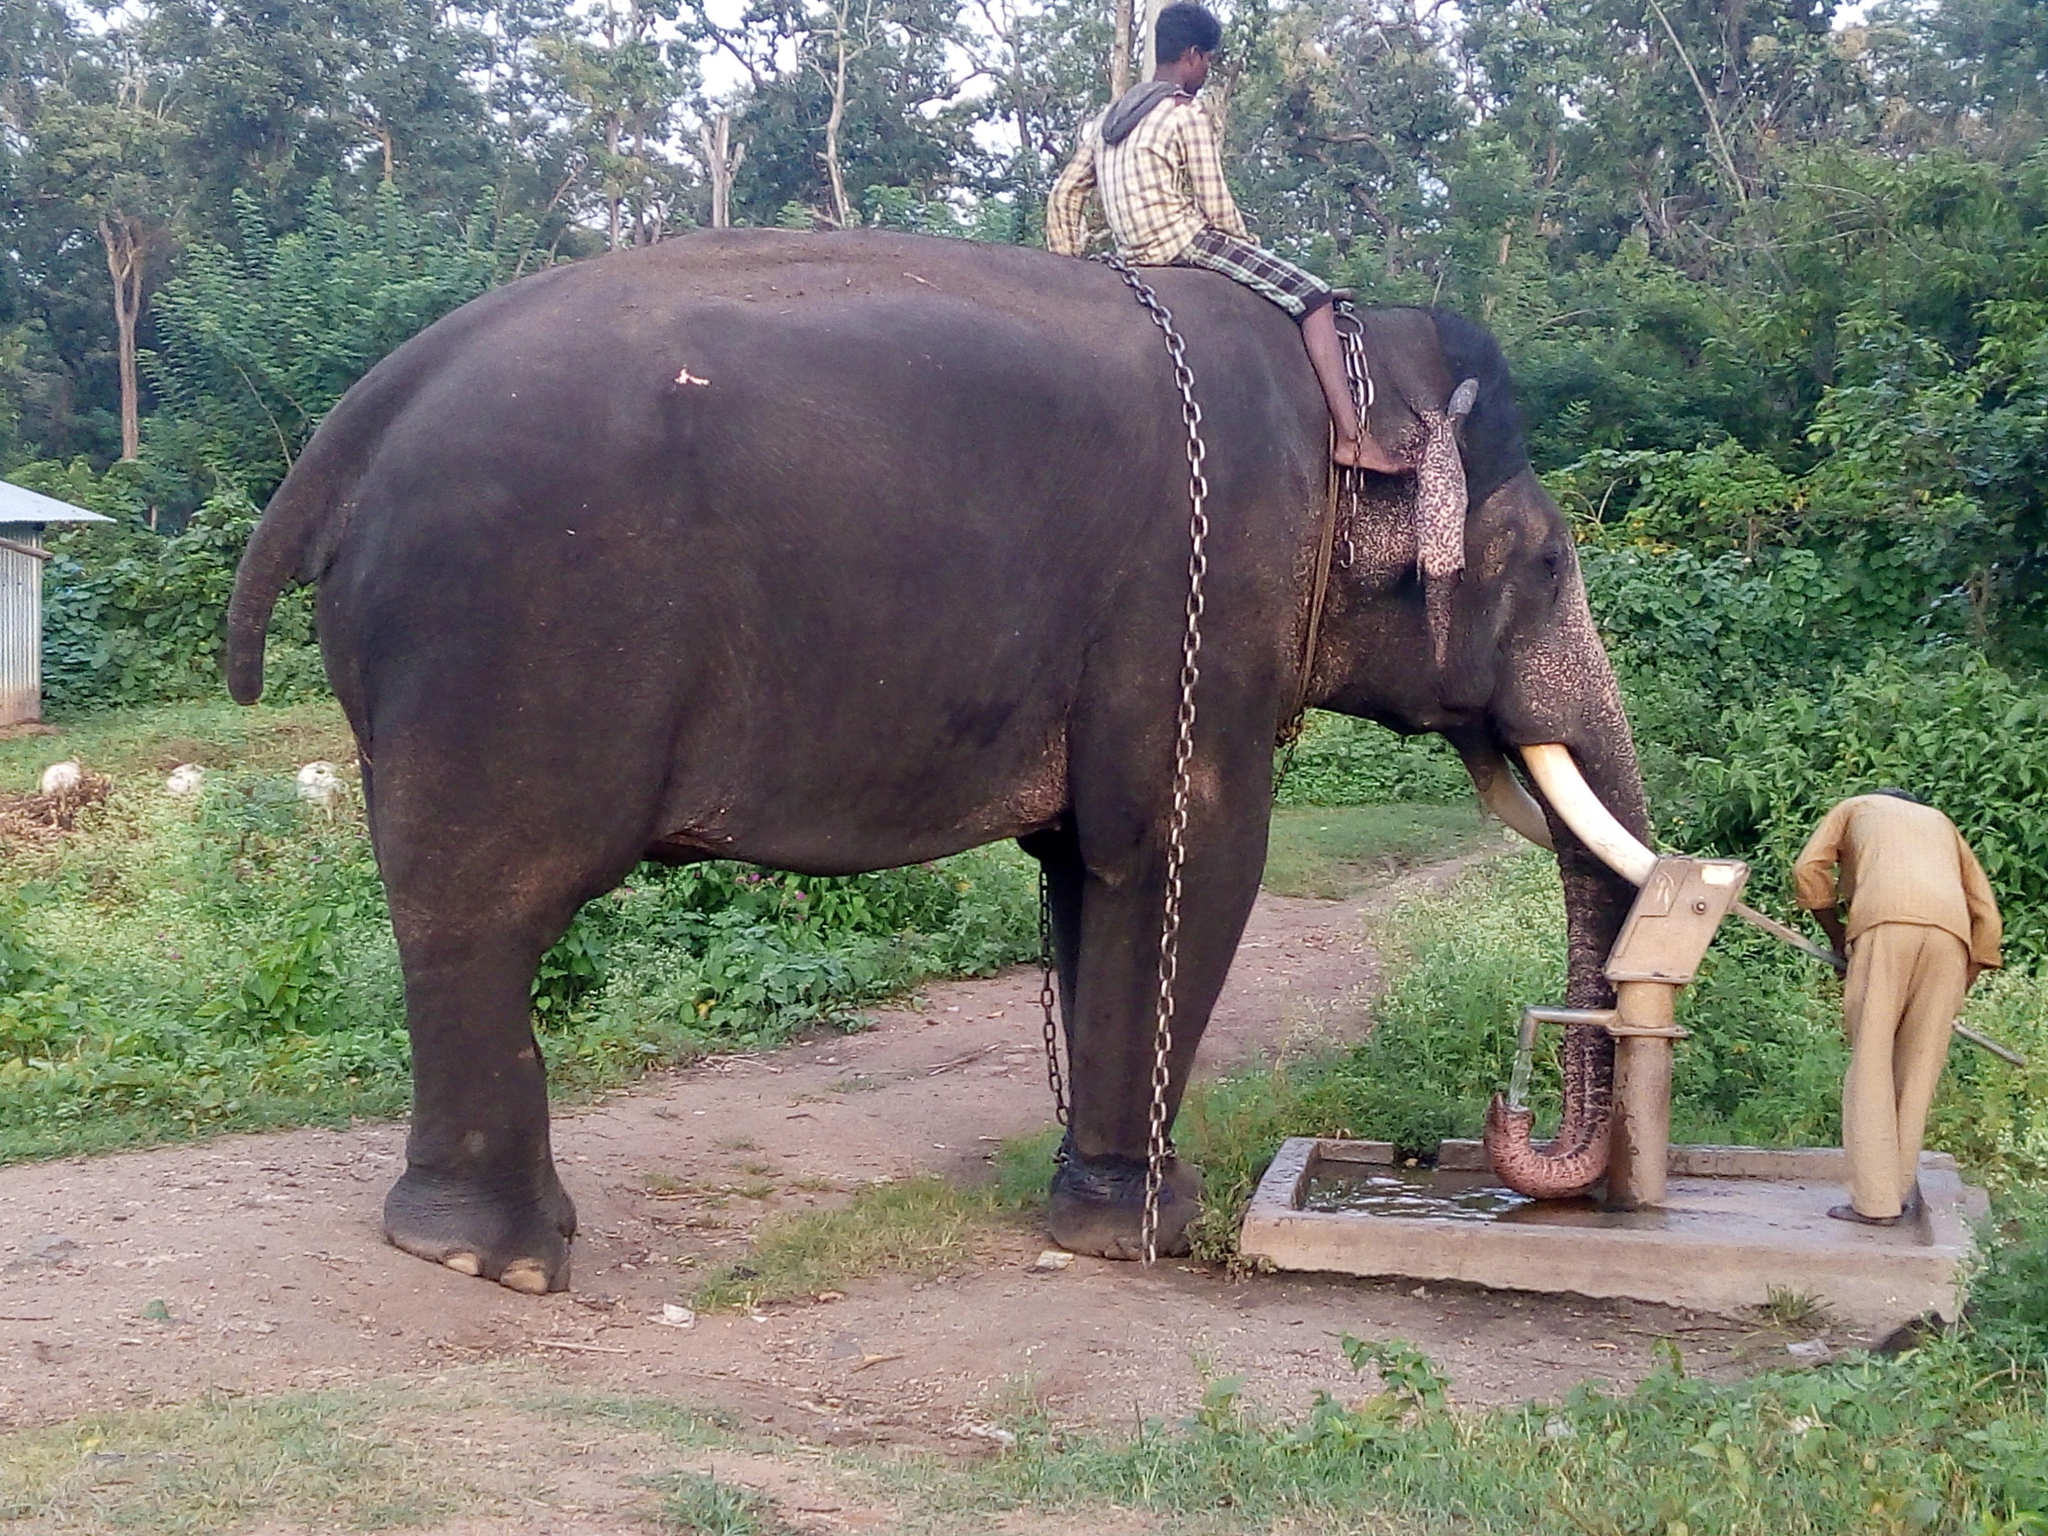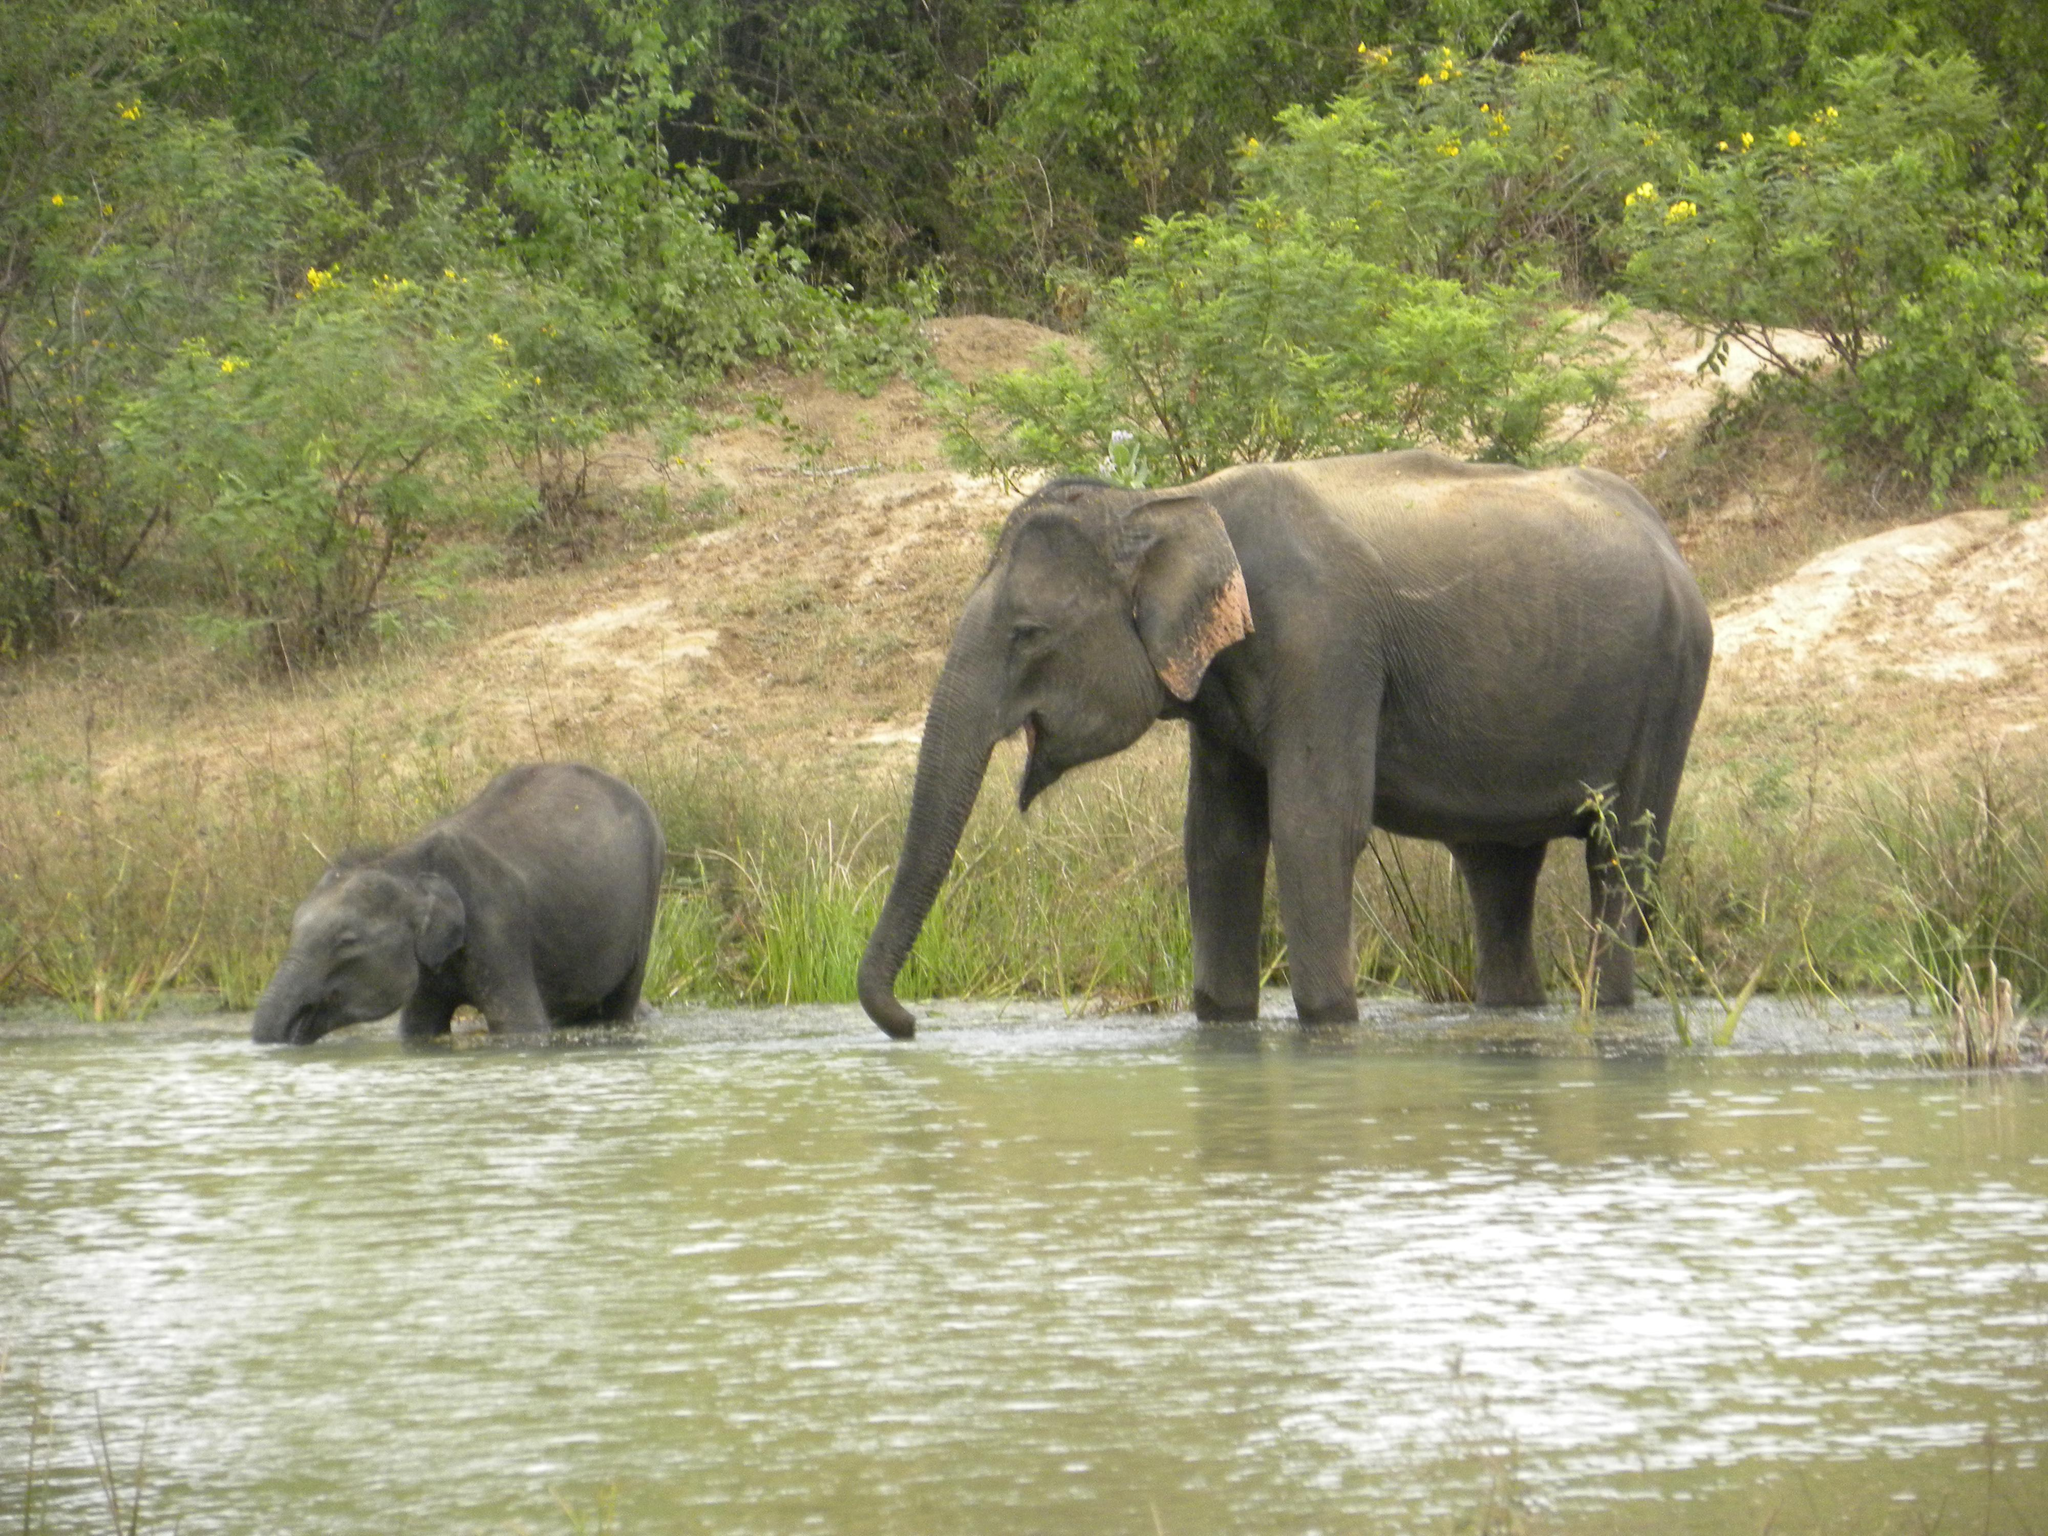The first image is the image on the left, the second image is the image on the right. For the images shown, is this caption "An image shows a person interacting with one elephant." true? Answer yes or no. Yes. The first image is the image on the left, the second image is the image on the right. Examine the images to the left and right. Is the description "There are no more than 4 elephants in total." accurate? Answer yes or no. Yes. 